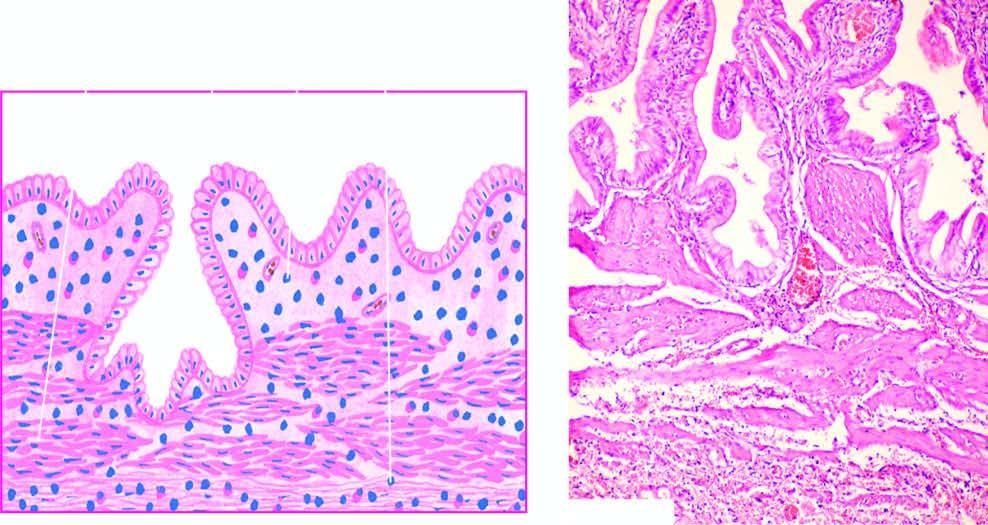s mononuclear inflammatory cell infiltrate present in subepithelial and perimuscular layers?
Answer the question using a single word or phrase. Yes 